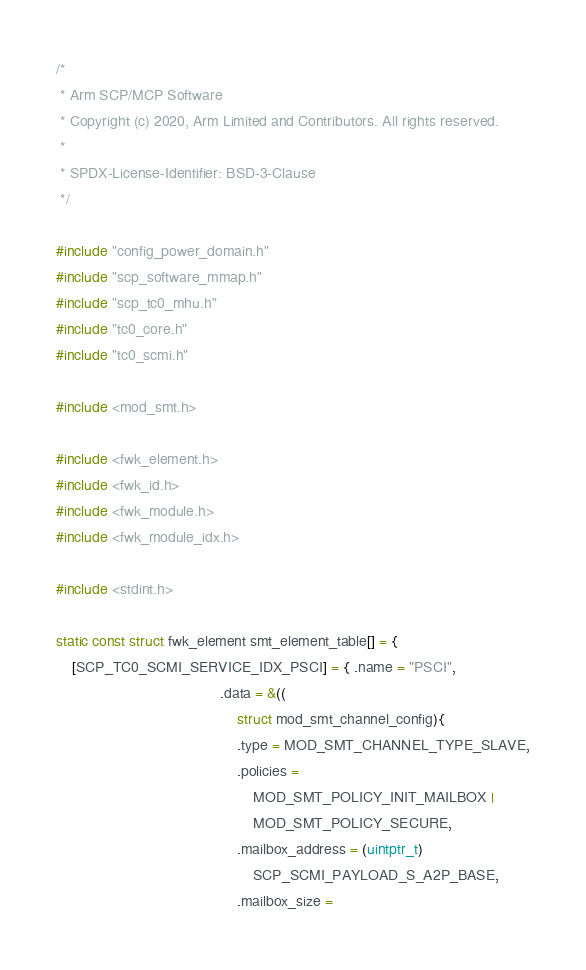<code> <loc_0><loc_0><loc_500><loc_500><_C_>/*
 * Arm SCP/MCP Software
 * Copyright (c) 2020, Arm Limited and Contributors. All rights reserved.
 *
 * SPDX-License-Identifier: BSD-3-Clause
 */

#include "config_power_domain.h"
#include "scp_software_mmap.h"
#include "scp_tc0_mhu.h"
#include "tc0_core.h"
#include "tc0_scmi.h"

#include <mod_smt.h>

#include <fwk_element.h>
#include <fwk_id.h>
#include <fwk_module.h>
#include <fwk_module_idx.h>

#include <stdint.h>

static const struct fwk_element smt_element_table[] = {
    [SCP_TC0_SCMI_SERVICE_IDX_PSCI] = { .name = "PSCI",
                                        .data = &((
                                            struct mod_smt_channel_config){
                                            .type = MOD_SMT_CHANNEL_TYPE_SLAVE,
                                            .policies =
                                                MOD_SMT_POLICY_INIT_MAILBOX |
                                                MOD_SMT_POLICY_SECURE,
                                            .mailbox_address = (uintptr_t)
                                                SCP_SCMI_PAYLOAD_S_A2P_BASE,
                                            .mailbox_size =</code> 